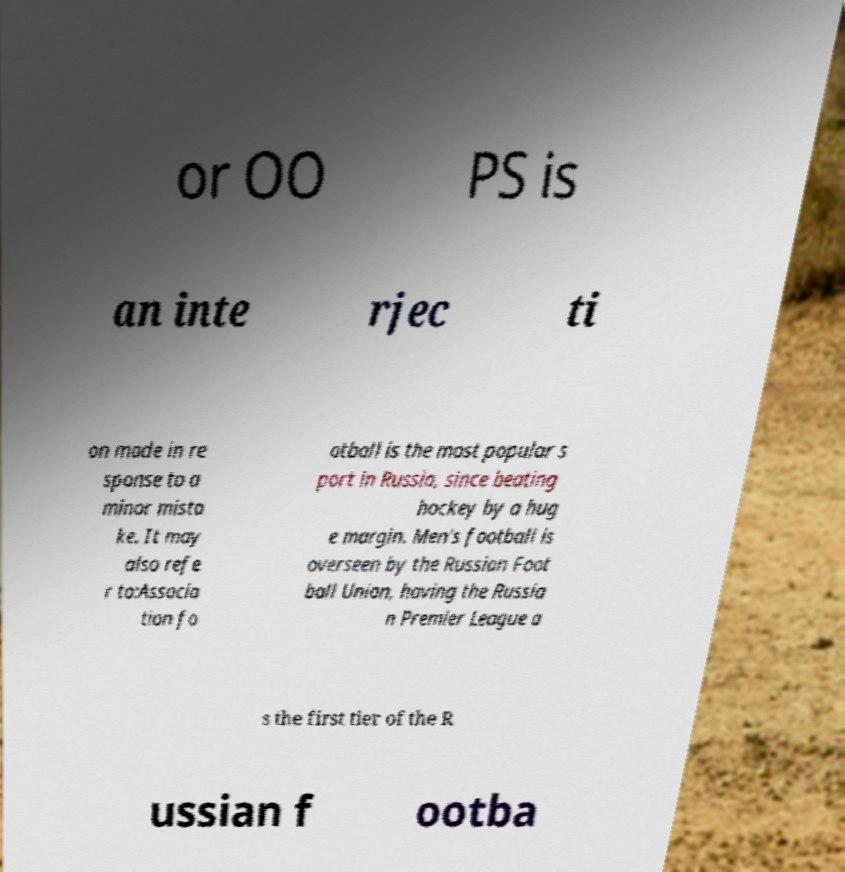Please read and relay the text visible in this image. What does it say? or OO PS is an inte rjec ti on made in re sponse to a minor mista ke. It may also refe r to:Associa tion fo otball is the most popular s port in Russia, since beating hockey by a hug e margin. Men's football is overseen by the Russian Foot ball Union, having the Russia n Premier League a s the first tier of the R ussian f ootba 